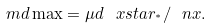<formula> <loc_0><loc_0><loc_500><loc_500>\ m d \max = \mu d \, \ x s t a r _ { ^ { * } } / \ n x .</formula> 